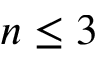<formula> <loc_0><loc_0><loc_500><loc_500>n \leq 3</formula> 